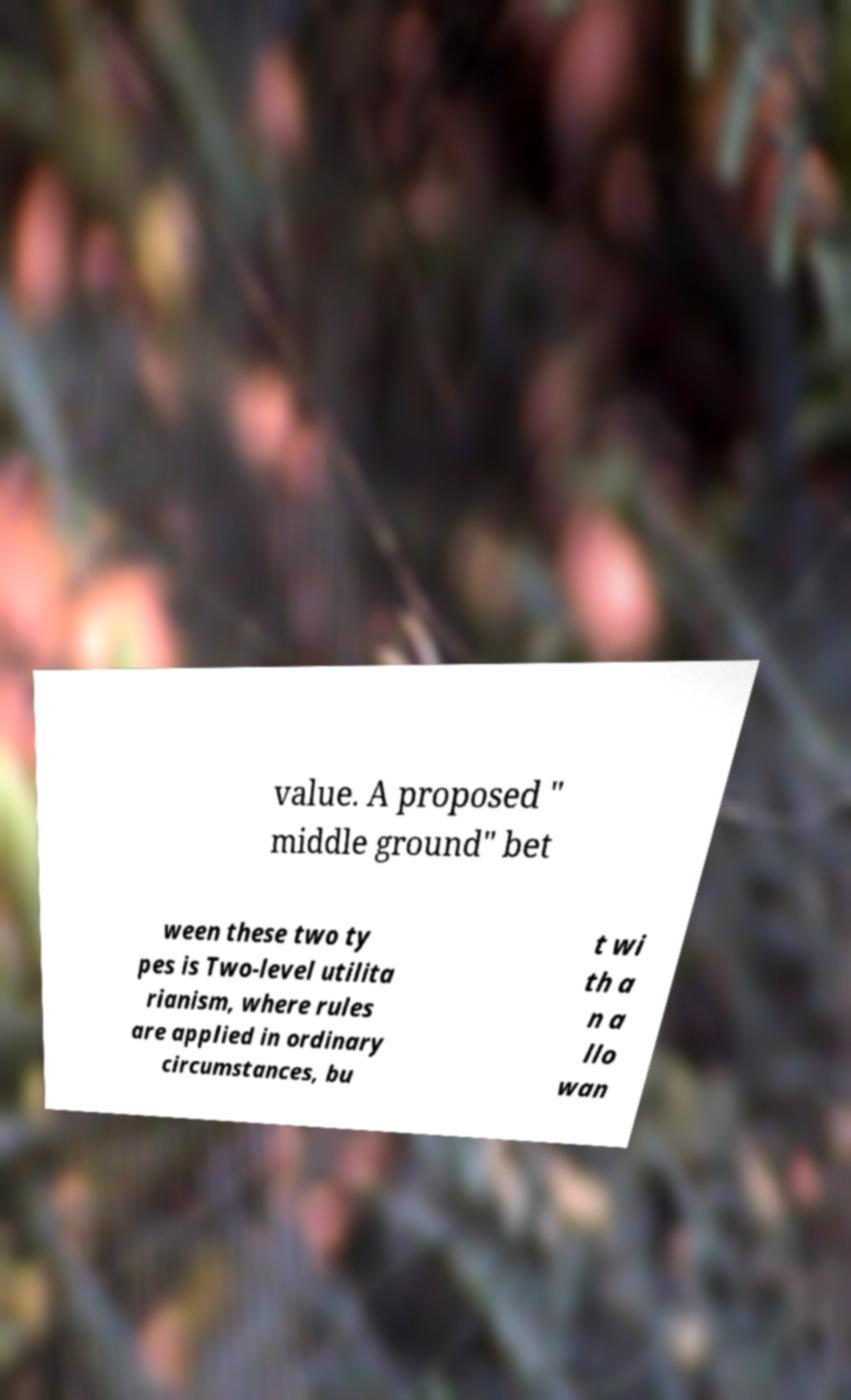Can you read and provide the text displayed in the image?This photo seems to have some interesting text. Can you extract and type it out for me? value. A proposed " middle ground" bet ween these two ty pes is Two-level utilita rianism, where rules are applied in ordinary circumstances, bu t wi th a n a llo wan 